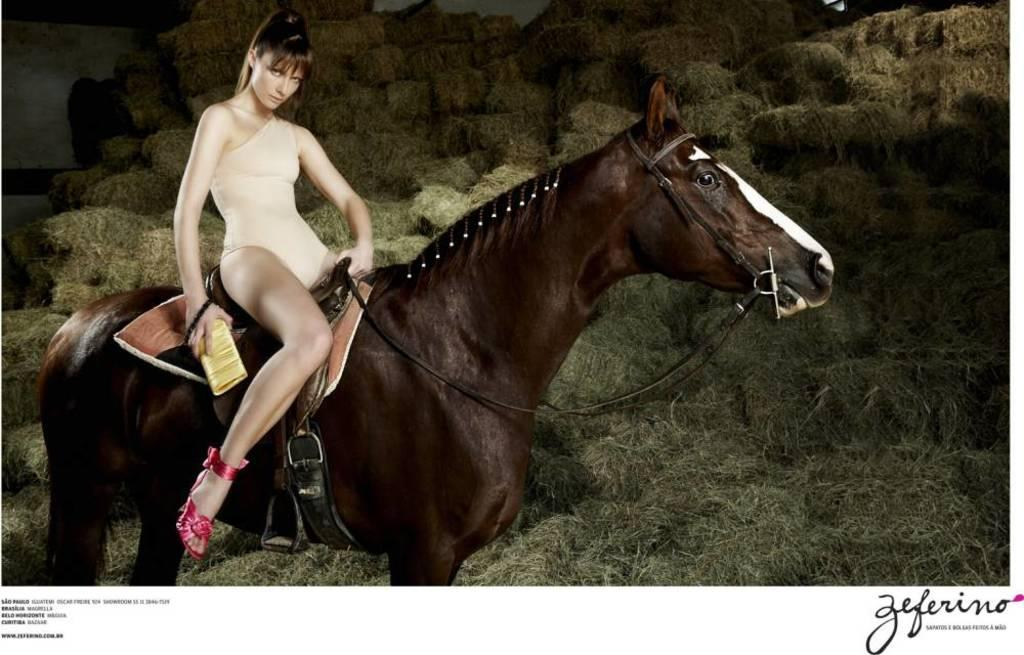Who is the main subject in the image? There is a woman in the image. What is the woman doing in the image? The woman is sitting on a horse. What is the woman holding in her hand? The woman is holding something in her hand. What type of environment is visible in the image? There is grass visible in the image. How many toy frogs can be seen in the image? There are no toy frogs present in the image. What is the woman saying good-bye to in the image? There is no indication in the image of the woman saying good-bye to anyone or anything. 